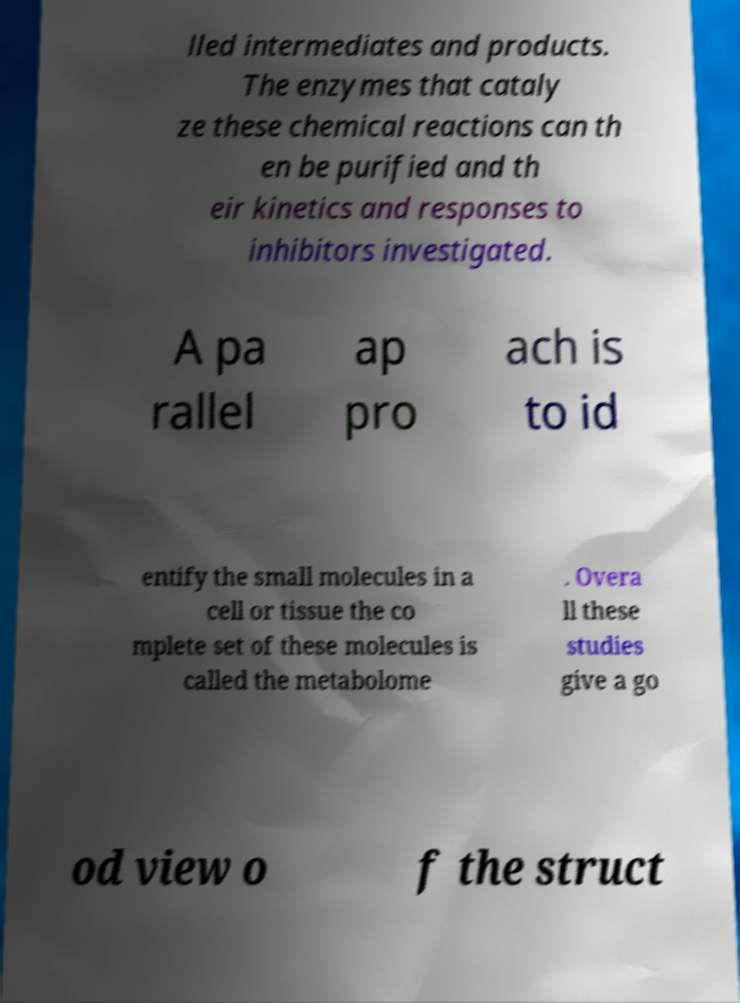Could you extract and type out the text from this image? lled intermediates and products. The enzymes that cataly ze these chemical reactions can th en be purified and th eir kinetics and responses to inhibitors investigated. A pa rallel ap pro ach is to id entify the small molecules in a cell or tissue the co mplete set of these molecules is called the metabolome . Overa ll these studies give a go od view o f the struct 